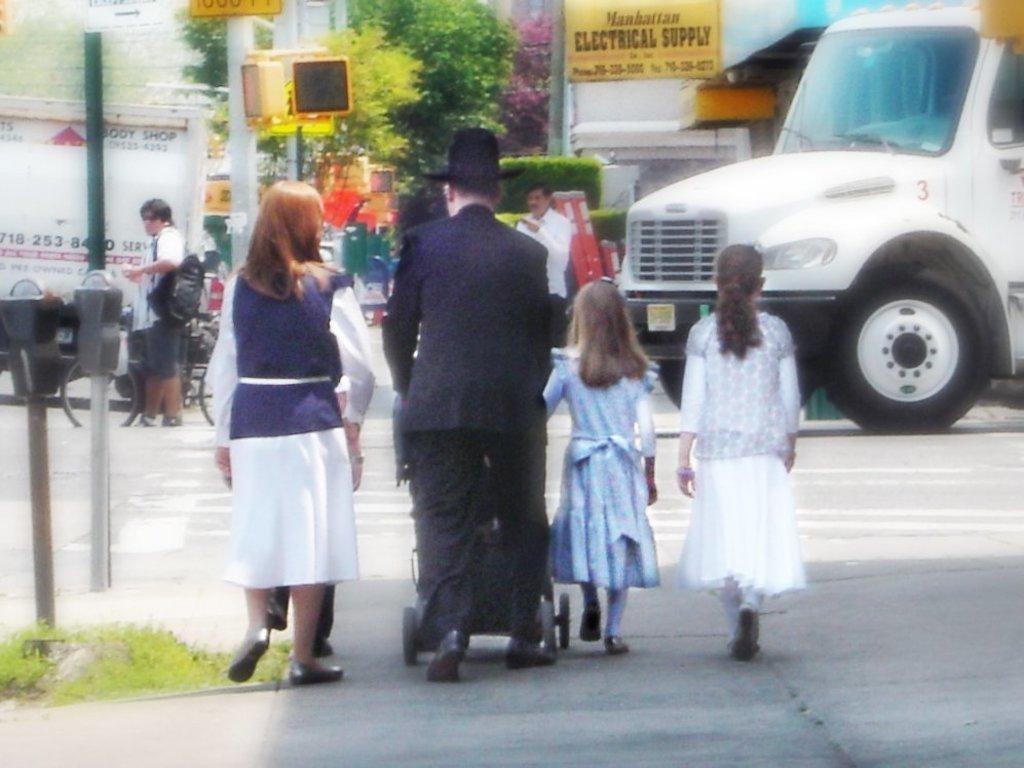Describe this image in one or two sentences. In this picture there is a man who is wearing hat, trouser and shoe. He is holding a baby trolley, beside him there is a woman who is wearing white dress, blue jacket and shoe. Beside him there are two girls who are walking on the road. In the back there is a man who is wearing white shirt and black trouser. He is standing near to the white track. On the left there is a man who is wearing goggles, bag, shirt, short and shoes. He is standing near to the bicycle. Beside him I can see the pole & boards. In the bottom left I can see the machine and grass. In the background I can see the buildings, banner, trees and poles 